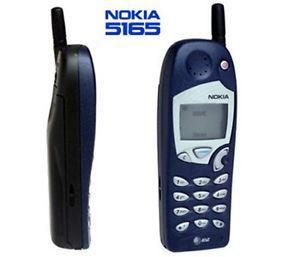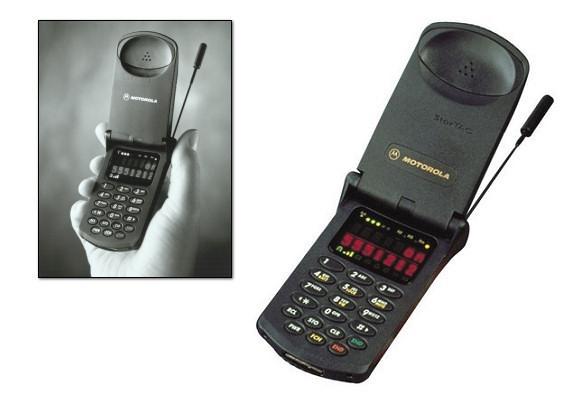The first image is the image on the left, the second image is the image on the right. Assess this claim about the two images: "The left image features a phone style that does not flip up and has a short antenna on the top and a rectangular display on the front, and the right image includes a phone with its lid flipped up.". Correct or not? Answer yes or no. Yes. The first image is the image on the left, the second image is the image on the right. Analyze the images presented: Is the assertion "A flip phone is in the open position in the image on the right." valid? Answer yes or no. Yes. 